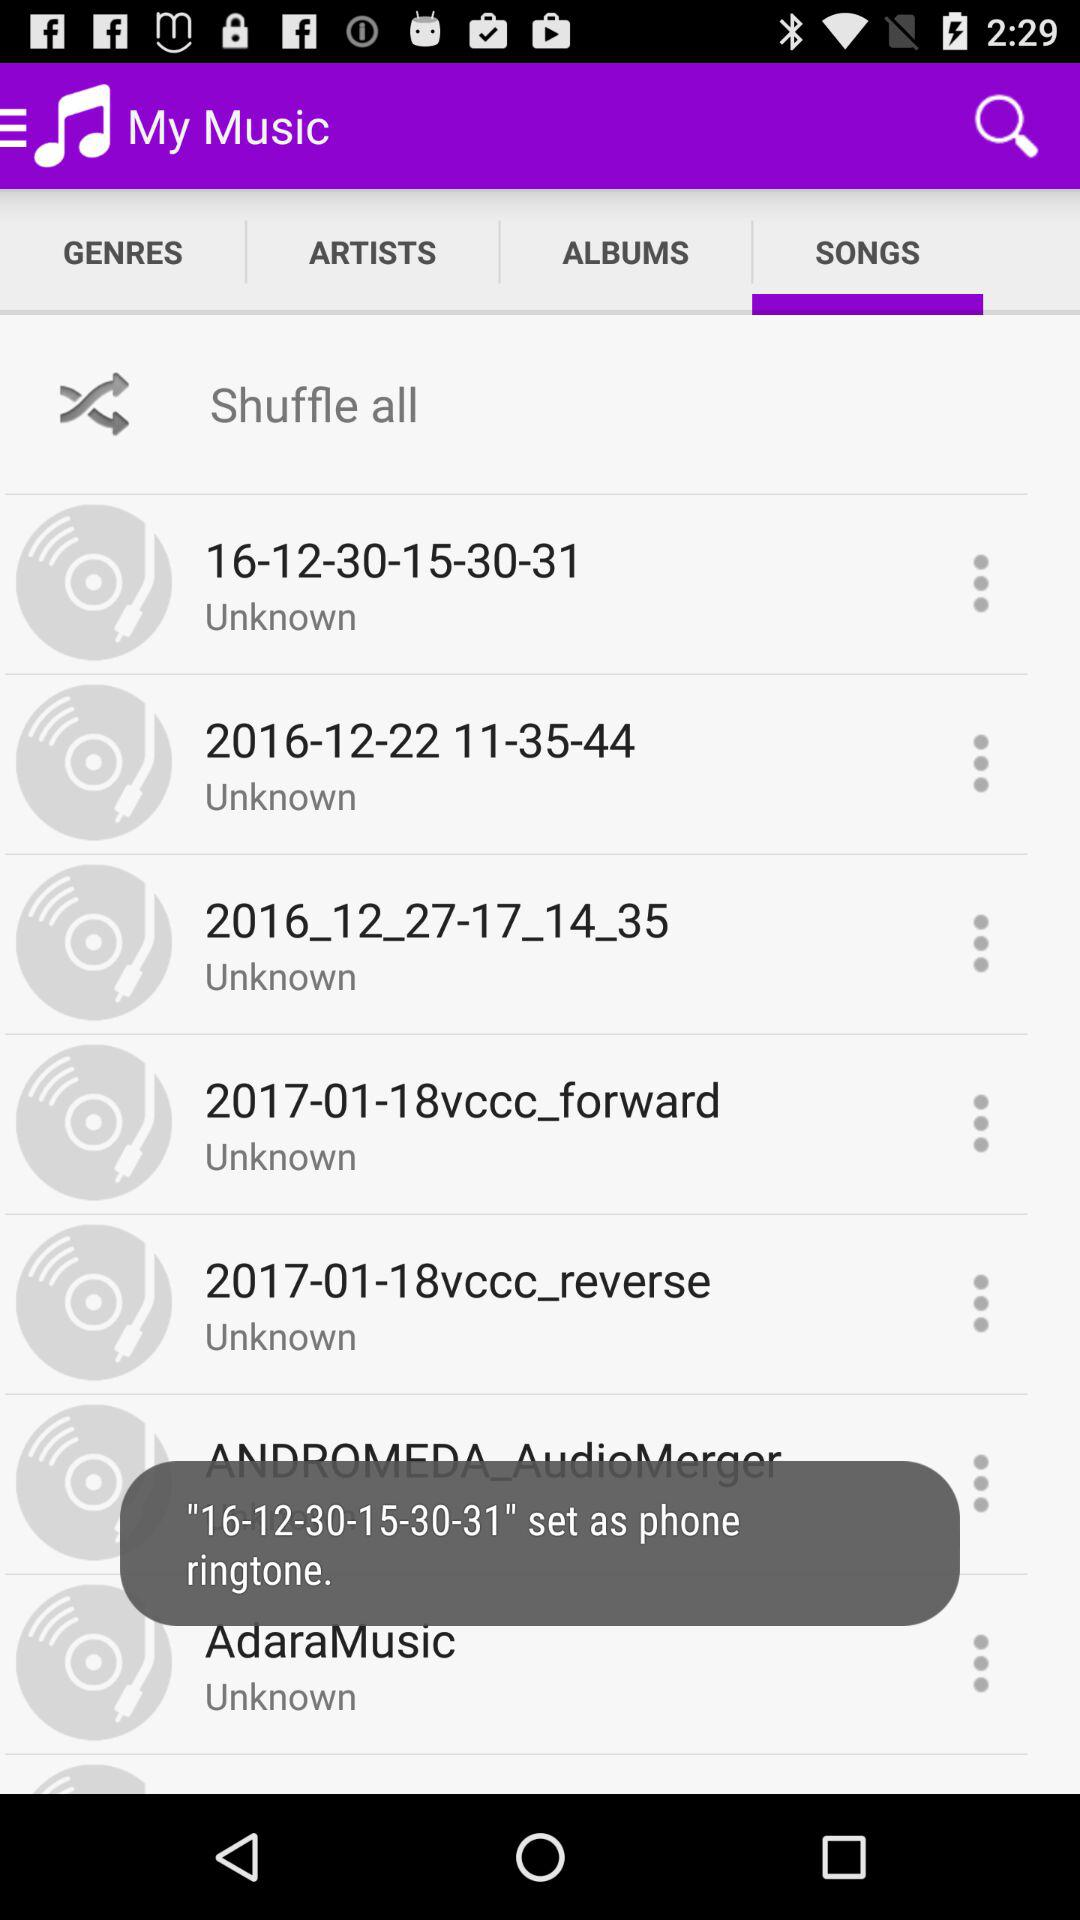Which tab is selected? The selected tab is "SONGS". 